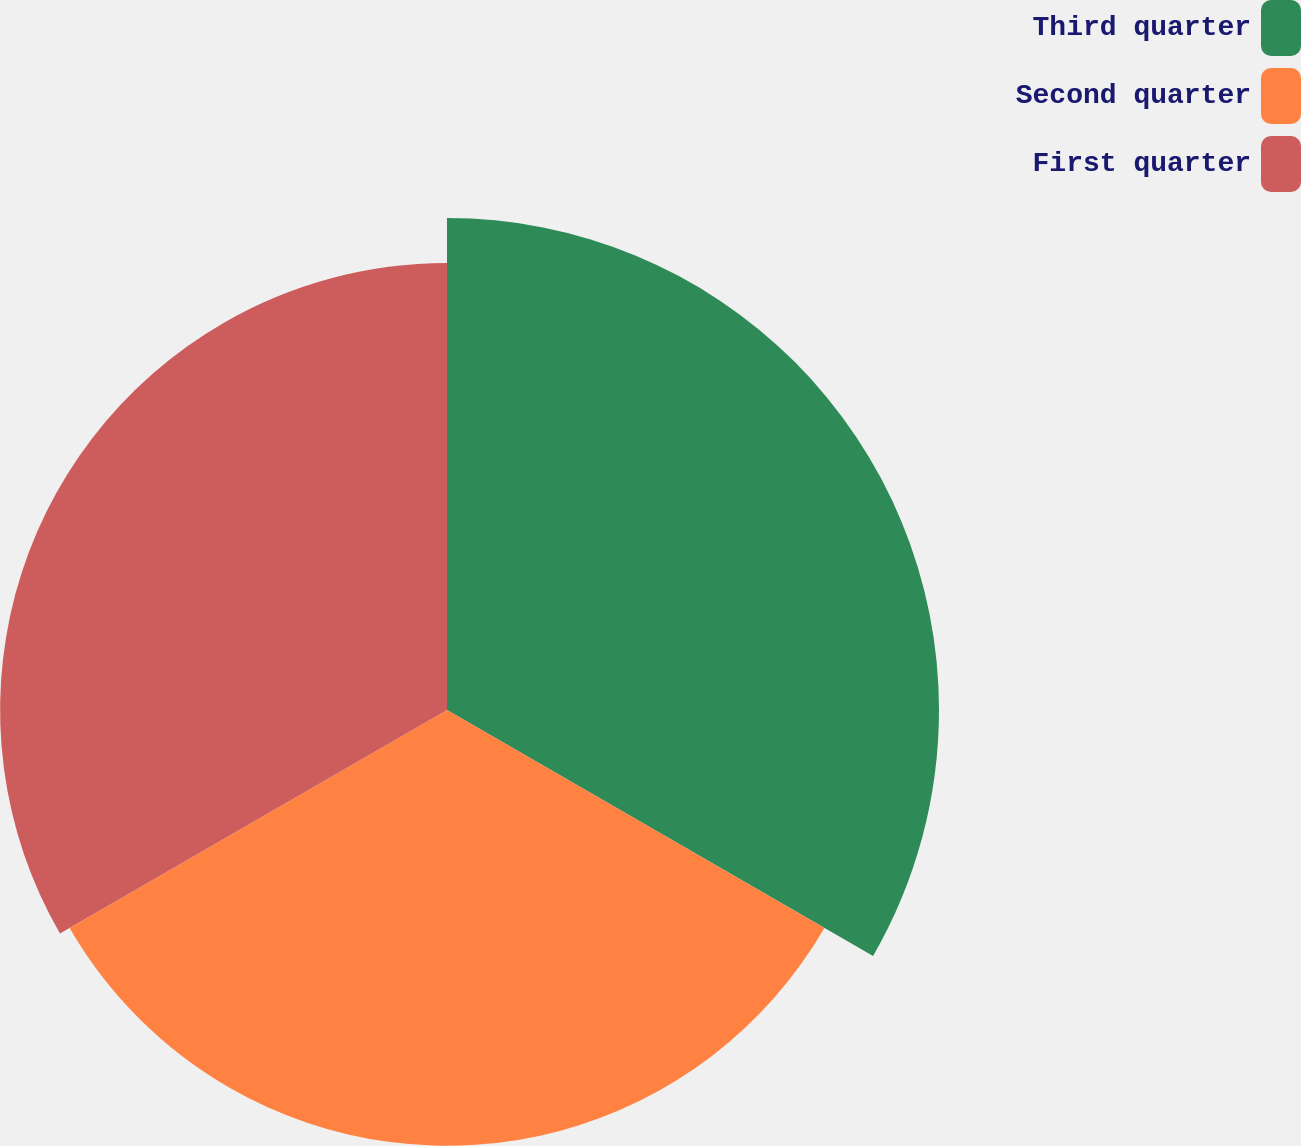Convert chart to OTSL. <chart><loc_0><loc_0><loc_500><loc_500><pie_chart><fcel>Third quarter<fcel>Second quarter<fcel>First quarter<nl><fcel>35.79%<fcel>31.7%<fcel>32.51%<nl></chart> 